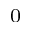Convert formula to latex. <formula><loc_0><loc_0><loc_500><loc_500>^ { 0 }</formula> 